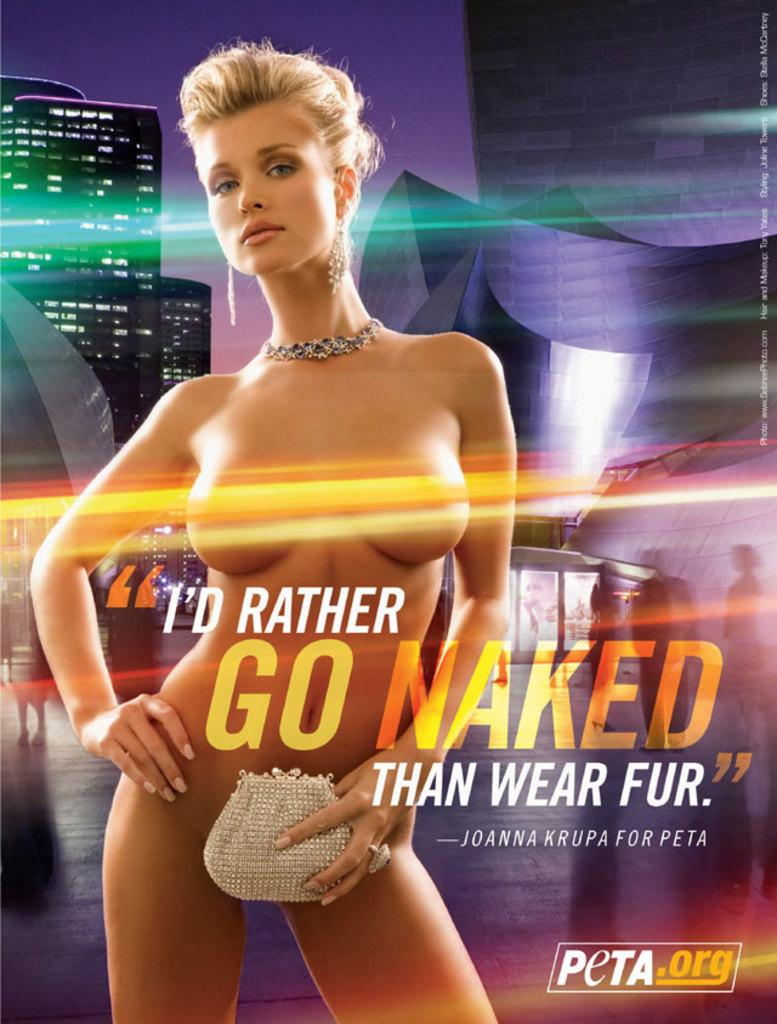Provide a one-sentence caption for the provided image. A bill board that says I'd Rather Go Naked than Wear Fur. 